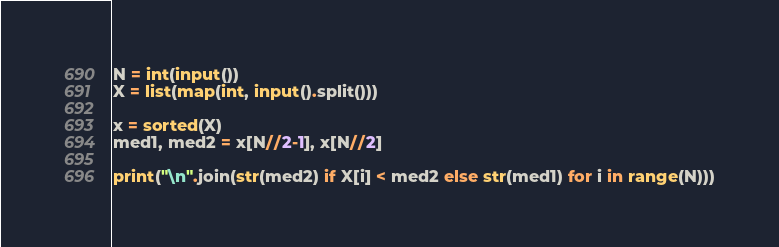<code> <loc_0><loc_0><loc_500><loc_500><_Python_>N = int(input())
X = list(map(int, input().split()))

x = sorted(X)
med1, med2 = x[N//2-1], x[N//2]

print("\n".join(str(med2) if X[i] < med2 else str(med1) for i in range(N)))
</code> 